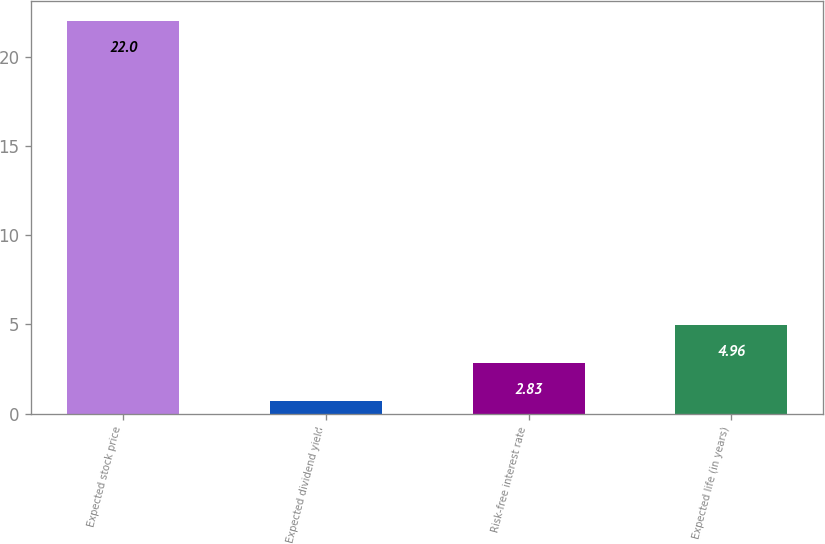Convert chart. <chart><loc_0><loc_0><loc_500><loc_500><bar_chart><fcel>Expected stock price<fcel>Expected dividend yield<fcel>Risk-free interest rate<fcel>Expected life (in years)<nl><fcel>22<fcel>0.7<fcel>2.83<fcel>4.96<nl></chart> 